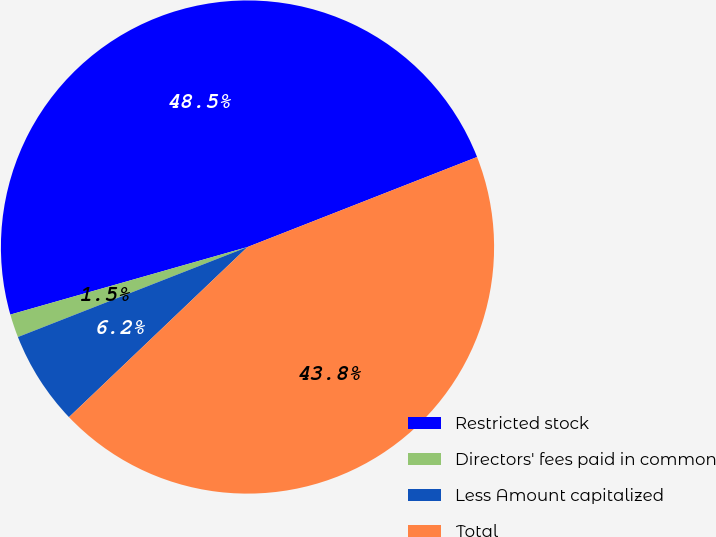<chart> <loc_0><loc_0><loc_500><loc_500><pie_chart><fcel>Restricted stock<fcel>Directors' fees paid in common<fcel>Less Amount capitalized<fcel>Total<nl><fcel>48.47%<fcel>1.53%<fcel>6.17%<fcel>43.83%<nl></chart> 